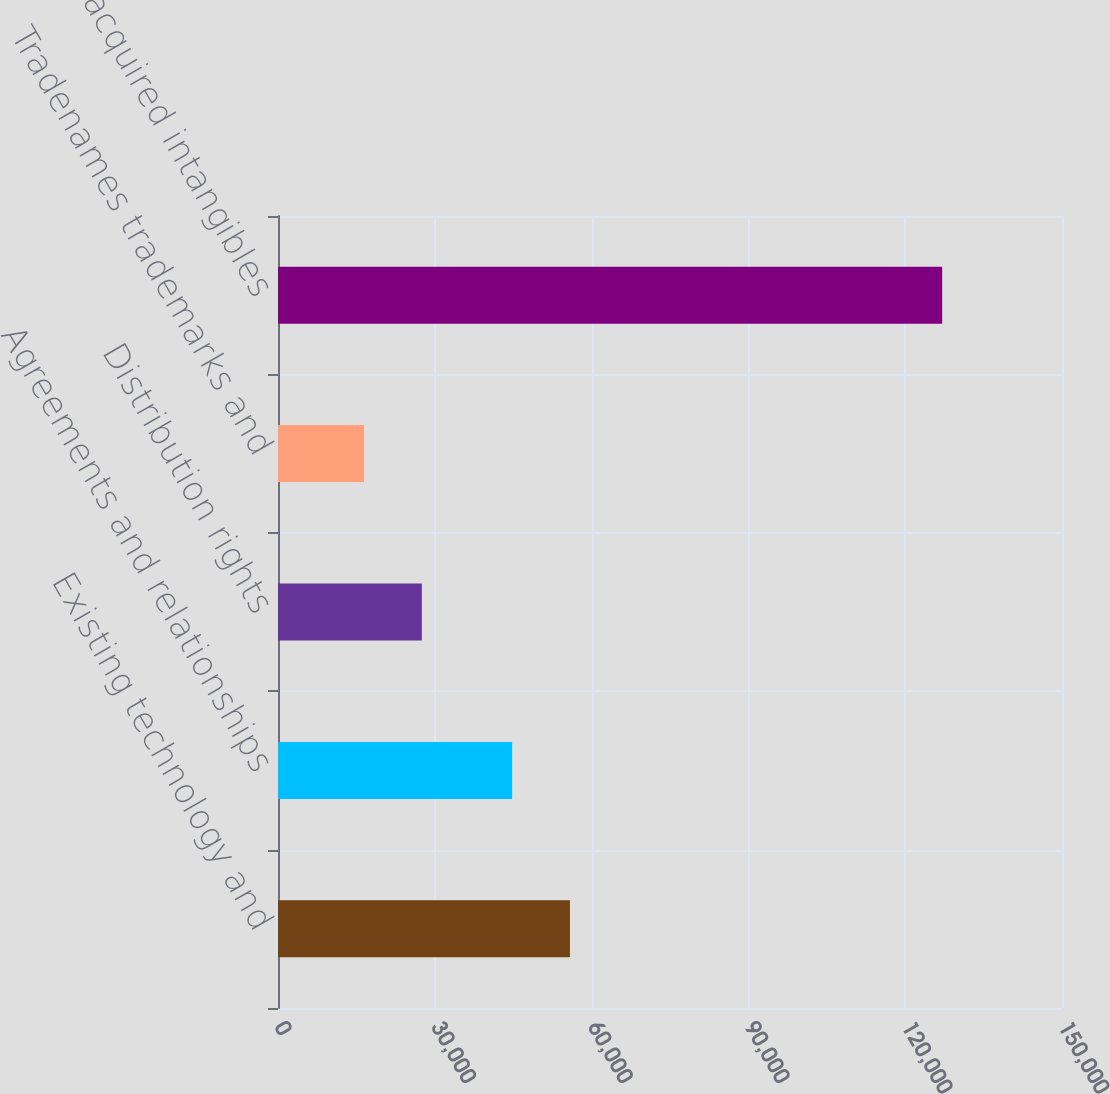<chart> <loc_0><loc_0><loc_500><loc_500><bar_chart><fcel>Existing technology and<fcel>Agreements and relationships<fcel>Distribution rights<fcel>Tradenames trademarks and<fcel>Total acquired intangibles<nl><fcel>55855.5<fcel>44794<fcel>27518.5<fcel>16457<fcel>127072<nl></chart> 